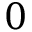<formula> <loc_0><loc_0><loc_500><loc_500>0</formula> 